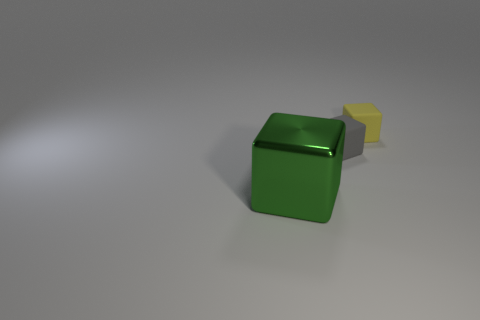Add 3 tiny blue rubber cylinders. How many objects exist? 6 Subtract all big green metallic blocks. Subtract all green objects. How many objects are left? 1 Add 1 metal objects. How many metal objects are left? 2 Add 3 big brown matte things. How many big brown matte things exist? 3 Subtract 0 red balls. How many objects are left? 3 